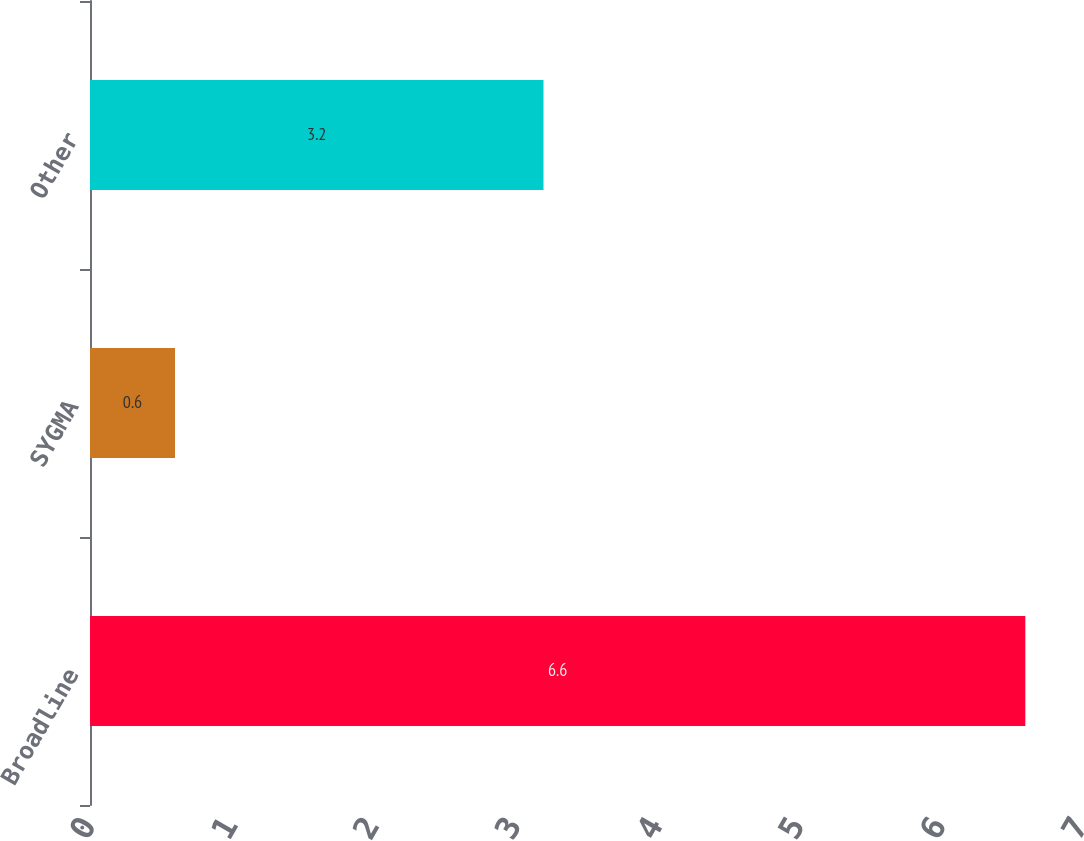Convert chart. <chart><loc_0><loc_0><loc_500><loc_500><bar_chart><fcel>Broadline<fcel>SYGMA<fcel>Other<nl><fcel>6.6<fcel>0.6<fcel>3.2<nl></chart> 